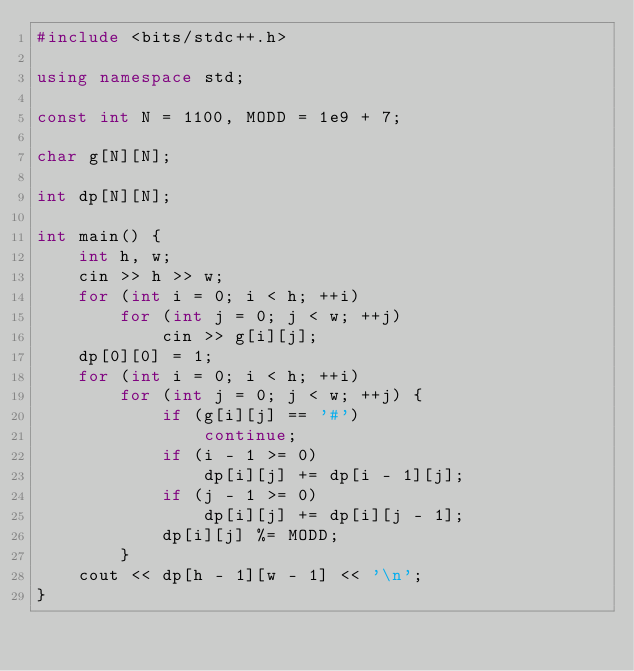<code> <loc_0><loc_0><loc_500><loc_500><_C++_>#include <bits/stdc++.h>

using namespace std;

const int N = 1100, MODD = 1e9 + 7;

char g[N][N];

int dp[N][N];

int main() {
	int h, w;
	cin >> h >> w;
	for (int i = 0; i < h; ++i)
		for (int j = 0; j < w; ++j)
			cin >> g[i][j];
	dp[0][0] = 1;
	for (int i = 0; i < h; ++i)
		for (int j = 0; j < w; ++j) {
			if (g[i][j] == '#')
				continue;
			if (i - 1 >= 0)
				dp[i][j] += dp[i - 1][j];
			if (j - 1 >= 0)
				dp[i][j] += dp[i][j - 1];
			dp[i][j] %= MODD;
		}
	cout << dp[h - 1][w - 1] << '\n';
}
</code> 